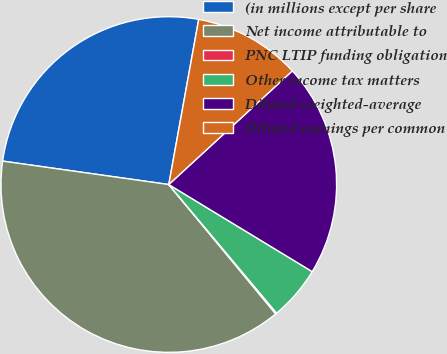<chart> <loc_0><loc_0><loc_500><loc_500><pie_chart><fcel>(in millions except per share<fcel>Net income attributable to<fcel>PNC LTIP funding obligation<fcel>Other income tax matters<fcel>Diluted weighted-average<fcel>Diluted earnings per common<nl><fcel>25.62%<fcel>38.22%<fcel>0.11%<fcel>5.21%<fcel>20.52%<fcel>10.31%<nl></chart> 